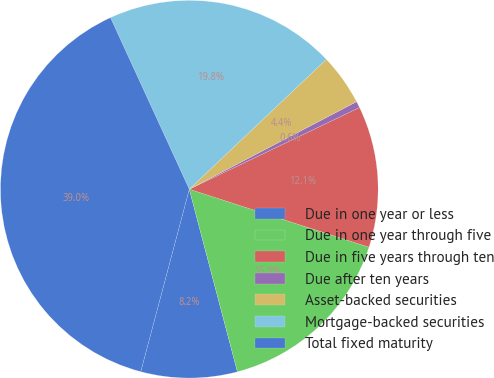<chart> <loc_0><loc_0><loc_500><loc_500><pie_chart><fcel>Due in one year or less<fcel>Due in one year through five<fcel>Due in five years through ten<fcel>Due after ten years<fcel>Asset-backed securities<fcel>Mortgage-backed securities<fcel>Total fixed maturity<nl><fcel>8.24%<fcel>15.93%<fcel>12.09%<fcel>0.55%<fcel>4.4%<fcel>19.78%<fcel>39.01%<nl></chart> 